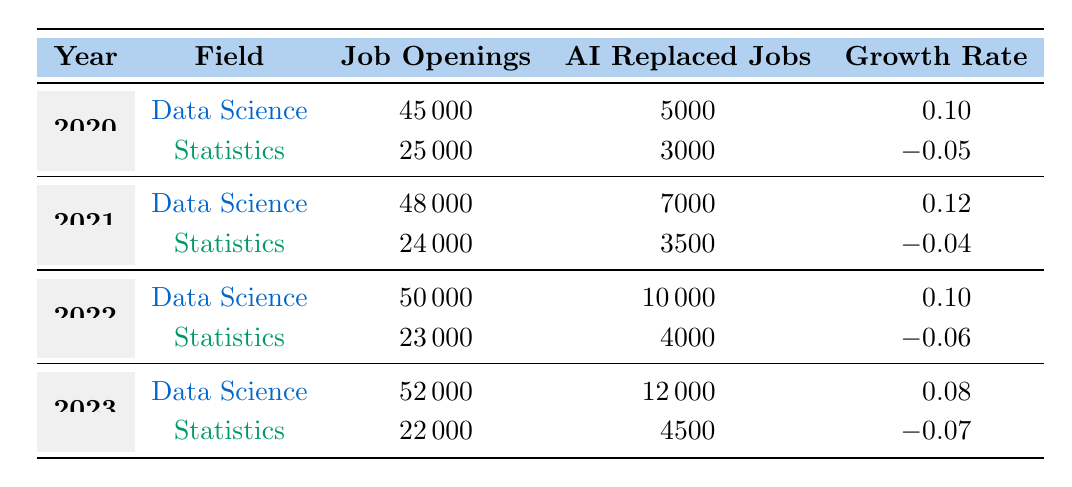What was the job opening count for Data Science in 2021? In the row corresponding to the year 2021 under the Data Science field, the job openings are listed as 48000.
Answer: 48000 How many jobs were replaced by AI in Statistics during 2022? The table indicates that in 2022, the number of AI replaced jobs in the Statistics field was 4000.
Answer: 4000 What was the total number of job openings for both fields combined in 2020? Adding the job openings for Data Science (45000) and Statistics (25000) in 2020 gives a total of 45000 + 25000 = 70000.
Answer: 70000 Is the growth rate for Data Science in 2023 higher than the growth rate for Statistics in the same year? The growth rate for Data Science in 2023 is 0.08, while for Statistics it is -0.07. Since 0.08 is greater than -0.07, the statement is true.
Answer: Yes What is the percentage decrease in job openings for Statistics from 2020 to 2023? The job openings for Statistics were 25000 in 2020 and decreased to 22000 in 2023. The decrease is 25000 - 22000 = 3000. To find the percentage decrease, (3000/25000) * 100 = 12%.
Answer: 12% What was the trend in AI replaced jobs for Data Science from 2020 to 2023? The AI replaced jobs for Data Science increased each year: from 5000 in 2020 to 12000 in 2023, indicating a growing trend.
Answer: Increasing Which year saw the highest growth rate in Statistics and what was it? Reviewing the growth rates for Statistics from the table, the highest was -0.04 in 2021.
Answer: -0.04 What is the average number of job openings for Data Science from 2020 to 2023? The job openings for Data Science over the years are 45000, 48000, 50000, and 52000. The total is 45000 + 48000 + 50000 + 52000 = 195000. The average is 195000 / 4 = 48750.
Answer: 48750 What can be concluded about the overall impact of AI on job growth in Statistics from 2020 to 2023? Statistics field saw a decline in job openings and negative growth rates throughout the years, suggesting that AI's impact has led to job reduction rather than growth.
Answer: Negative impact 